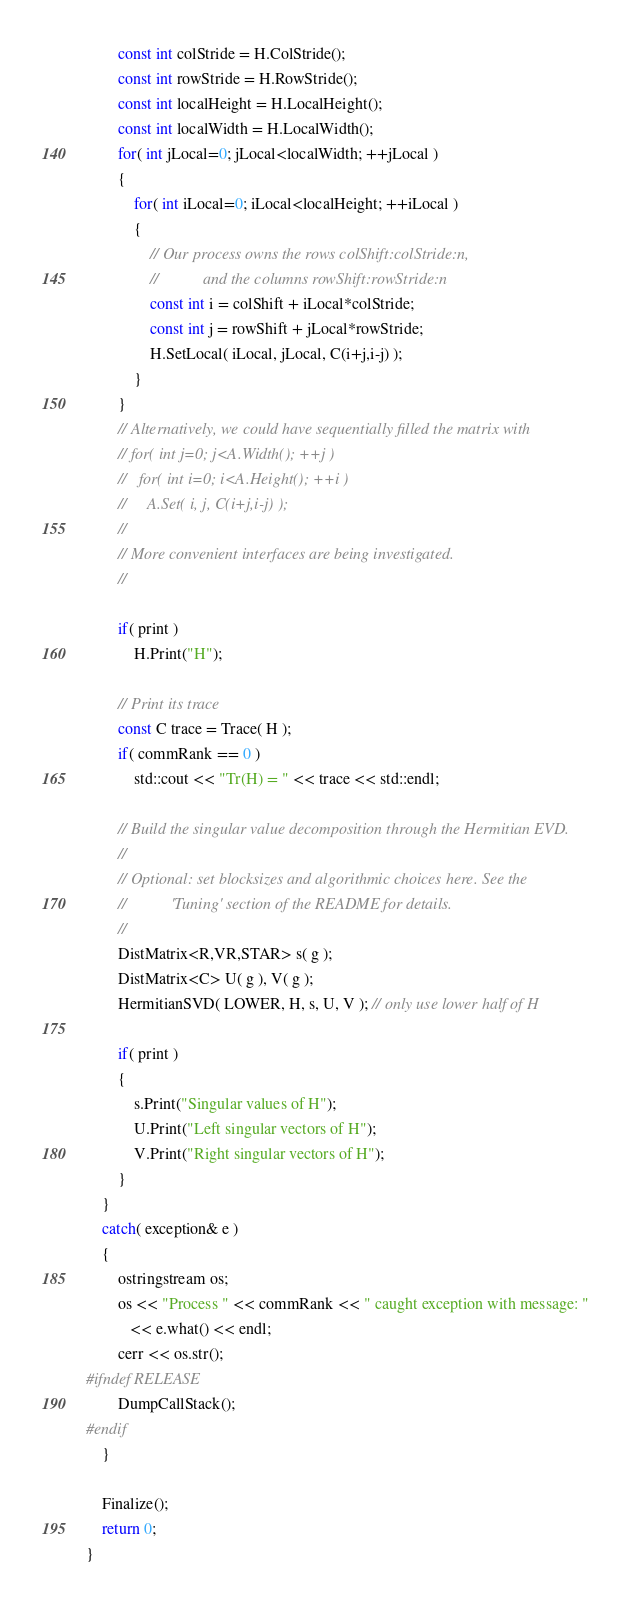<code> <loc_0><loc_0><loc_500><loc_500><_C++_>        const int colStride = H.ColStride();
        const int rowStride = H.RowStride();
        const int localHeight = H.LocalHeight();
        const int localWidth = H.LocalWidth();
        for( int jLocal=0; jLocal<localWidth; ++jLocal )
        {
            for( int iLocal=0; iLocal<localHeight; ++iLocal )
            {
                // Our process owns the rows colShift:colStride:n,
                //           and the columns rowShift:rowStride:n
                const int i = colShift + iLocal*colStride;
                const int j = rowShift + jLocal*rowStride;
                H.SetLocal( iLocal, jLocal, C(i+j,i-j) );
            }
        }
        // Alternatively, we could have sequentially filled the matrix with 
        // for( int j=0; j<A.Width(); ++j )
        //   for( int i=0; i<A.Height(); ++i )
        //     A.Set( i, j, C(i+j,i-j) );
        //
        // More convenient interfaces are being investigated.
        //

        if( print )
            H.Print("H");

        // Print its trace
        const C trace = Trace( H );
        if( commRank == 0 )
            std::cout << "Tr(H) = " << trace << std::endl;

        // Build the singular value decomposition through the Hermitian EVD.
        //
        // Optional: set blocksizes and algorithmic choices here. See the 
        //           'Tuning' section of the README for details.
        //
        DistMatrix<R,VR,STAR> s( g );
        DistMatrix<C> U( g ), V( g );
        HermitianSVD( LOWER, H, s, U, V ); // only use lower half of H

        if( print )
        {
            s.Print("Singular values of H");
            U.Print("Left singular vectors of H");
            V.Print("Right singular vectors of H");
        }
    }
    catch( exception& e )
    {
        ostringstream os;
        os << "Process " << commRank << " caught exception with message: "
           << e.what() << endl;
        cerr << os.str();
#ifndef RELEASE
        DumpCallStack();
#endif
    }

    Finalize();
    return 0;
}

</code> 